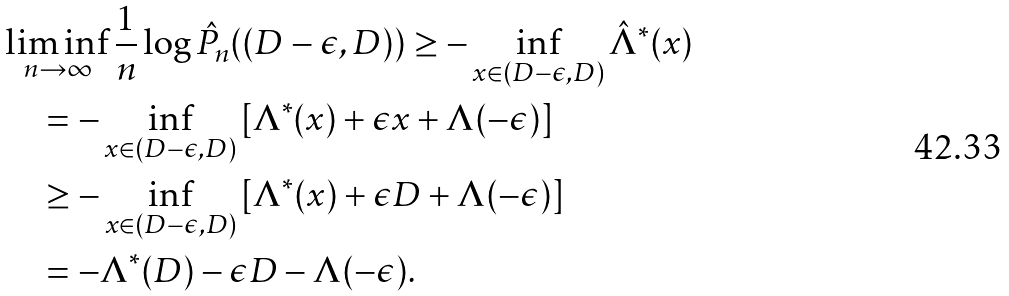<formula> <loc_0><loc_0><loc_500><loc_500>& \liminf _ { n \to \infty } \frac { 1 } { n } \log \hat { P } _ { n } ( ( D - \epsilon , D ) ) \geq - \inf _ { x \in ( D - \epsilon , D ) } \hat { \Lambda } ^ { * } ( x ) \\ & \quad = - \inf _ { x \in ( D - \epsilon , D ) } \left [ \Lambda ^ { * } ( x ) + \epsilon x + \Lambda ( - \epsilon ) \right ] \\ & \quad \geq - \inf _ { x \in ( D - \epsilon , D ) } \left [ \Lambda ^ { * } ( x ) + \epsilon D + \Lambda ( - \epsilon ) \right ] \\ & \quad = - \Lambda ^ { * } ( D ) - \epsilon D - \Lambda ( - \epsilon ) .</formula> 